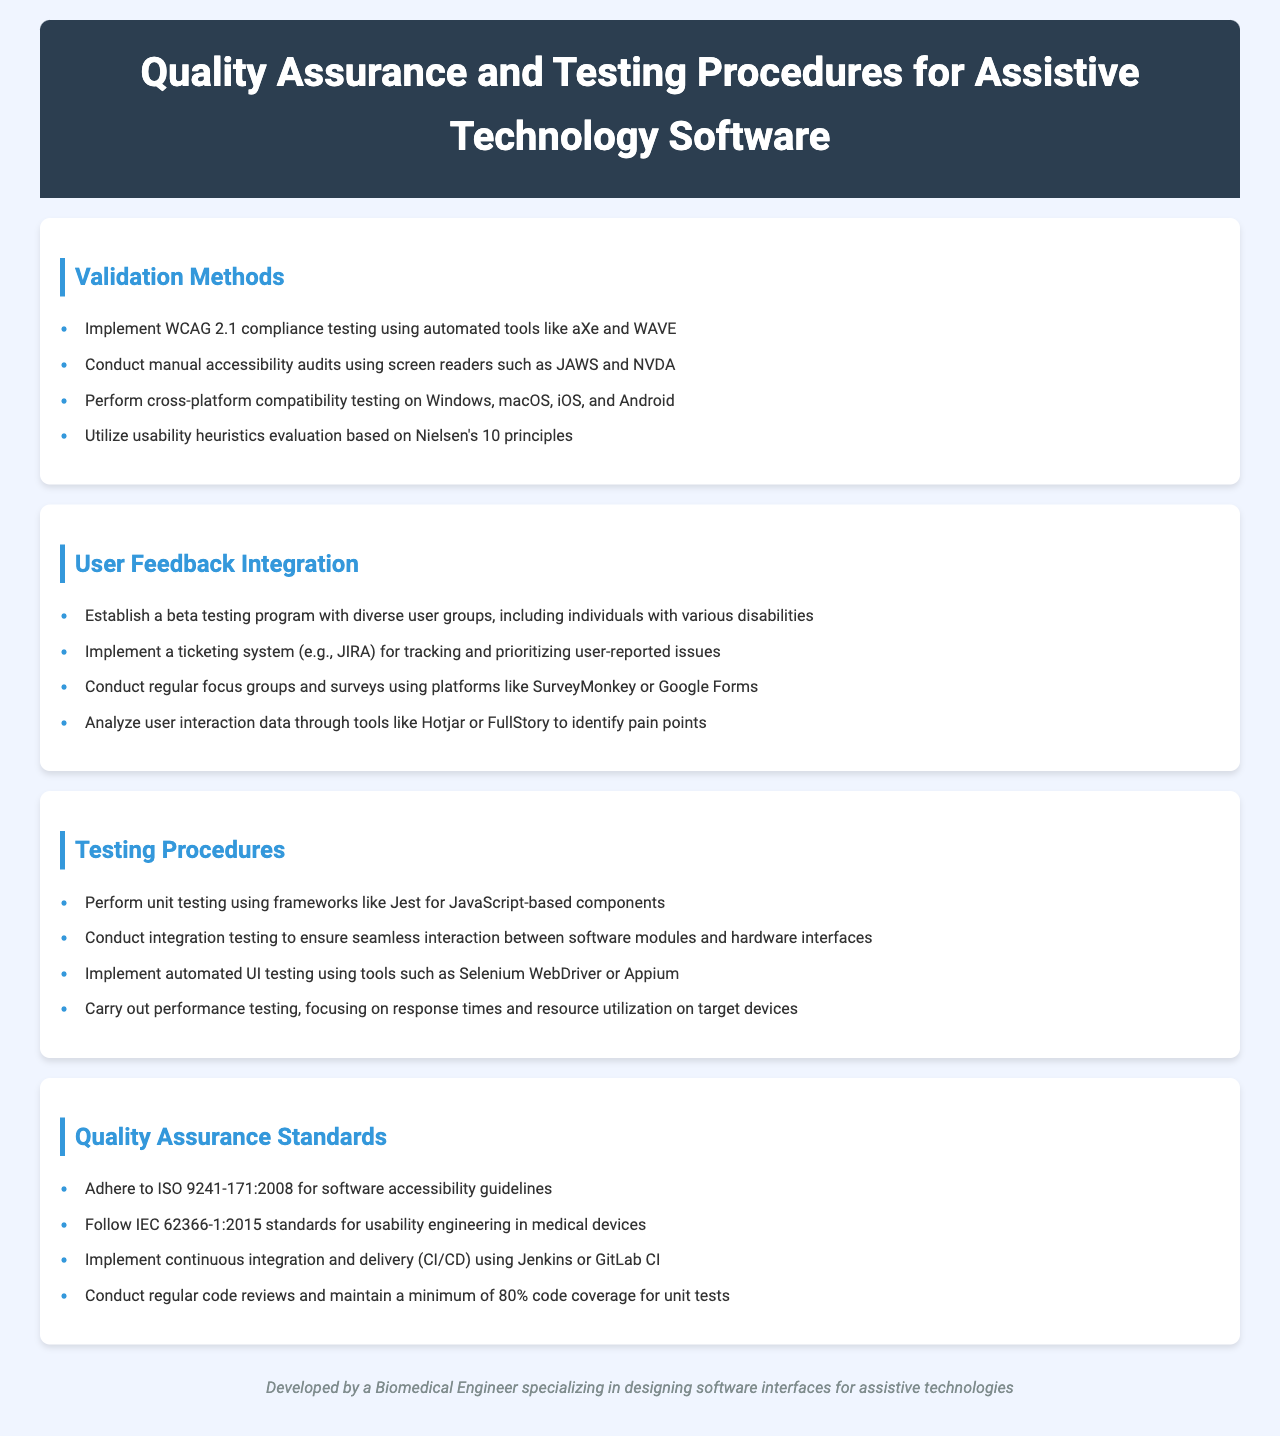What is the title of the document? The title is presented prominently at the top of the document.
Answer: Quality Assurance and Testing Procedures for Assistive Technology Software How many validation methods are listed? The section lists several validation methods. Counting the items, there are four methods mentioned.
Answer: 4 What testing framework is recommended for unit testing? The document specifies which frameworks are appropriate for unit testing in the relevant section.
Answer: Jest What standards are followed for usability engineering in medical devices? This information can be found in the Quality Assurance Standards section.
Answer: IEC 62366-1:2015 What tool is suggested for analyzing user interaction data? The document mentions specific tools for analyzing user data.
Answer: Hotjar What is the purpose of the beta testing program? The document states a specific goal of establishing a beta testing program.
Answer: Diverse user groups Which method should be used to track user-reported issues? The document specifies a system for tracking user-reported issues in the User Feedback Integration section.
Answer: JIRA What is the minimum code coverage recommended for unit tests? The document sets a standard for code coverage in the Quality Assurance Standards section.
Answer: 80% Name one automated UI testing tool mentioned. The document lists various tools for automated UI testing.
Answer: Selenium WebDriver 